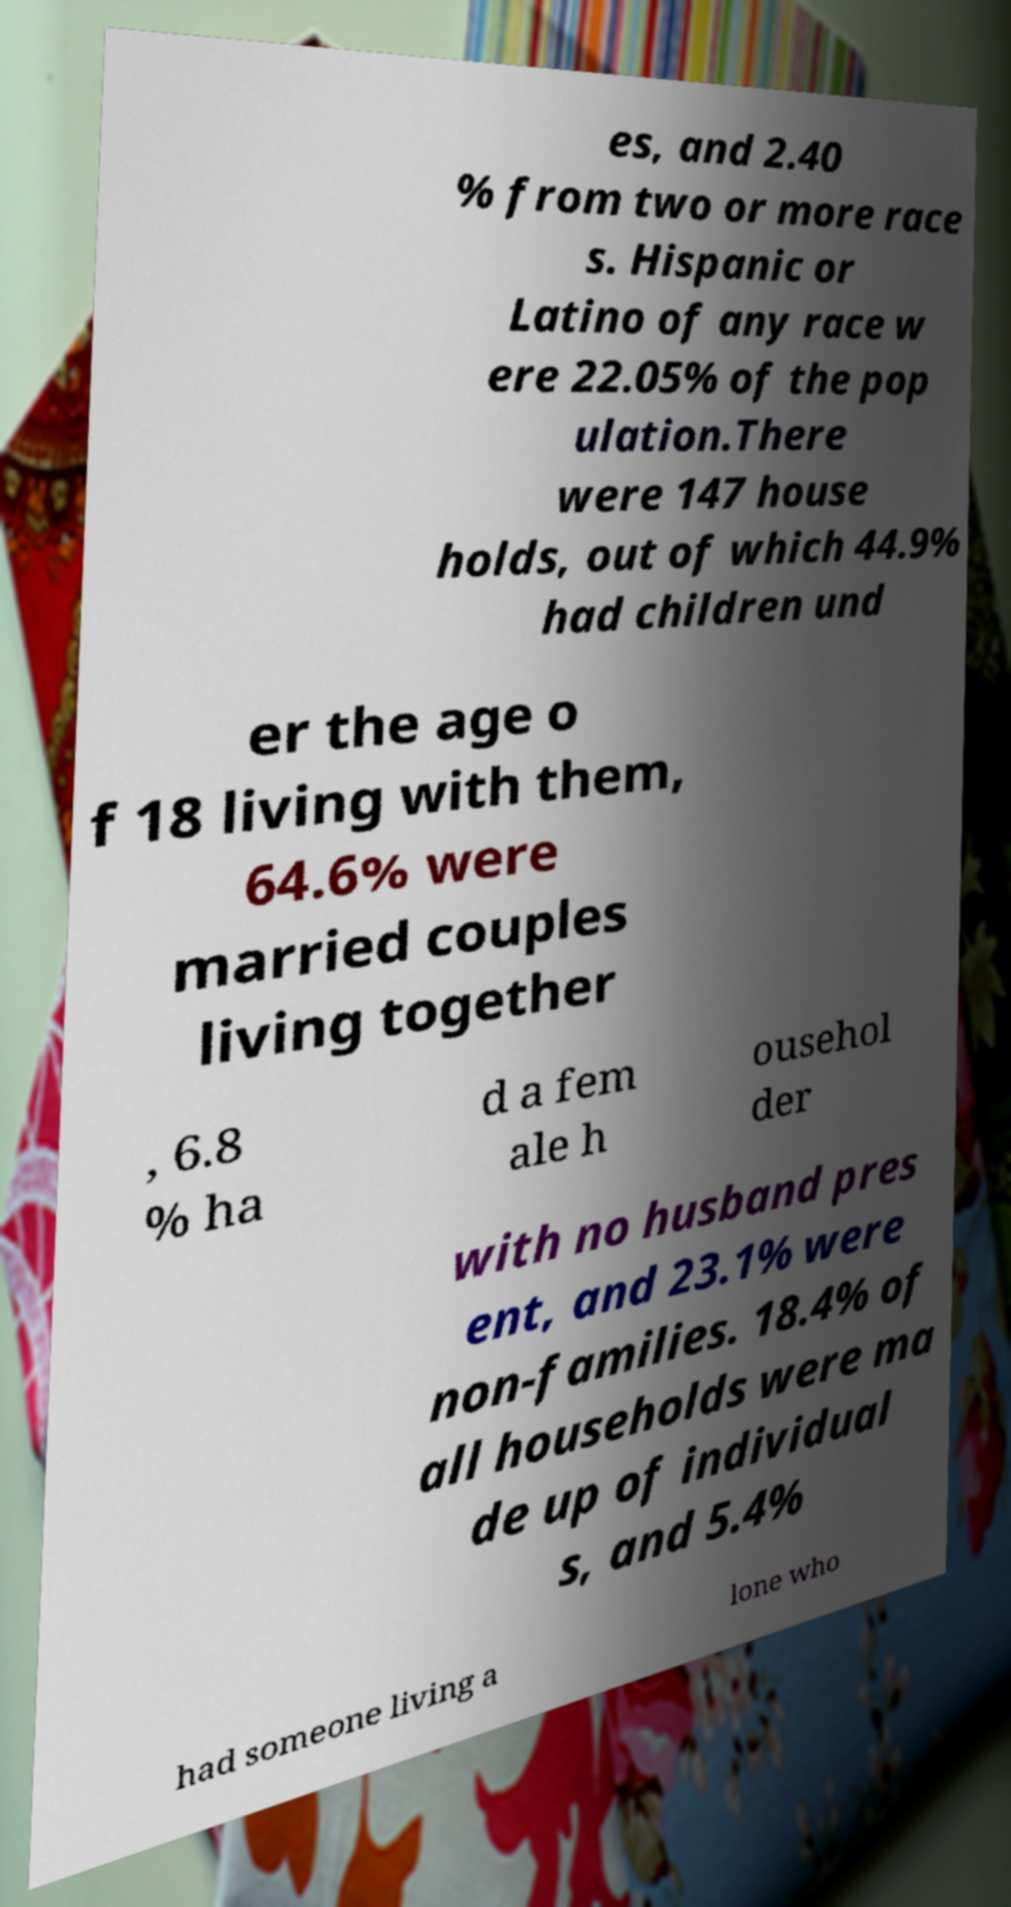Can you accurately transcribe the text from the provided image for me? es, and 2.40 % from two or more race s. Hispanic or Latino of any race w ere 22.05% of the pop ulation.There were 147 house holds, out of which 44.9% had children und er the age o f 18 living with them, 64.6% were married couples living together , 6.8 % ha d a fem ale h ousehol der with no husband pres ent, and 23.1% were non-families. 18.4% of all households were ma de up of individual s, and 5.4% had someone living a lone who 